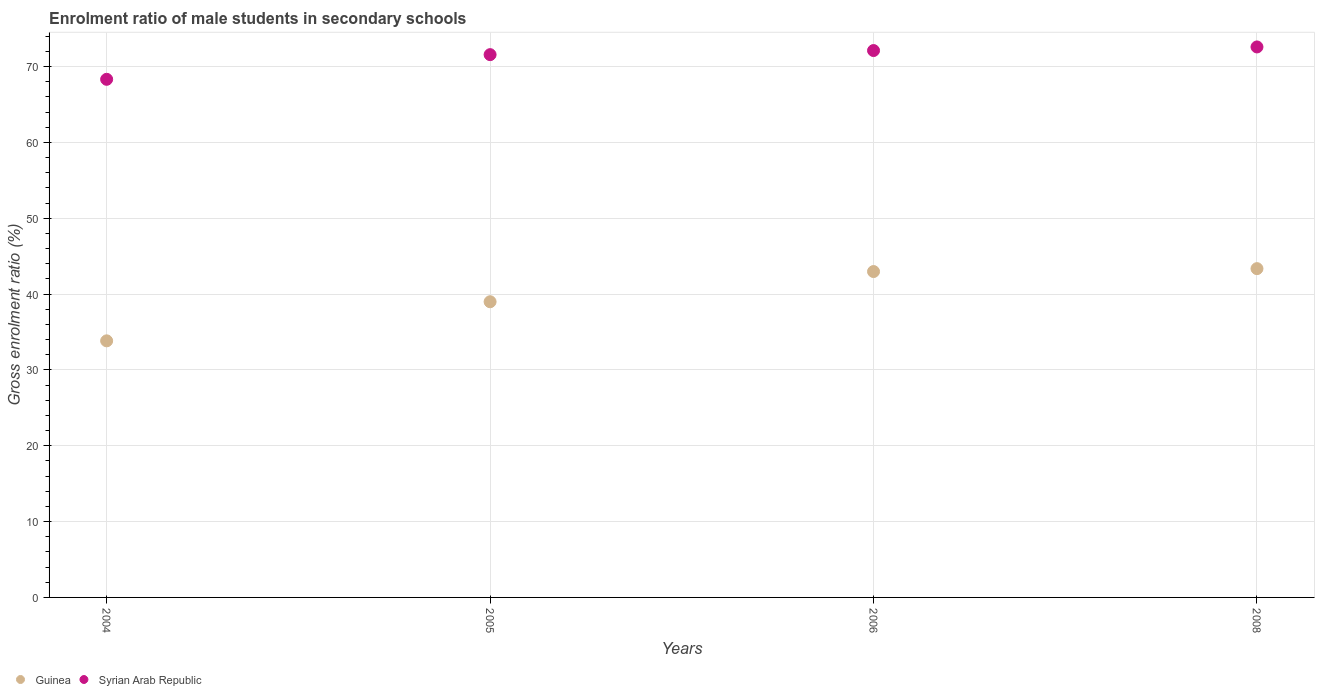What is the enrolment ratio of male students in secondary schools in Guinea in 2004?
Give a very brief answer. 33.84. Across all years, what is the maximum enrolment ratio of male students in secondary schools in Guinea?
Provide a succinct answer. 43.36. Across all years, what is the minimum enrolment ratio of male students in secondary schools in Syrian Arab Republic?
Your answer should be very brief. 68.33. In which year was the enrolment ratio of male students in secondary schools in Syrian Arab Republic maximum?
Make the answer very short. 2008. In which year was the enrolment ratio of male students in secondary schools in Guinea minimum?
Keep it short and to the point. 2004. What is the total enrolment ratio of male students in secondary schools in Syrian Arab Republic in the graph?
Ensure brevity in your answer.  284.63. What is the difference between the enrolment ratio of male students in secondary schools in Syrian Arab Republic in 2006 and that in 2008?
Make the answer very short. -0.48. What is the difference between the enrolment ratio of male students in secondary schools in Guinea in 2006 and the enrolment ratio of male students in secondary schools in Syrian Arab Republic in 2008?
Your response must be concise. -29.62. What is the average enrolment ratio of male students in secondary schools in Guinea per year?
Provide a succinct answer. 39.79. In the year 2005, what is the difference between the enrolment ratio of male students in secondary schools in Syrian Arab Republic and enrolment ratio of male students in secondary schools in Guinea?
Make the answer very short. 32.59. What is the ratio of the enrolment ratio of male students in secondary schools in Syrian Arab Republic in 2004 to that in 2006?
Keep it short and to the point. 0.95. Is the enrolment ratio of male students in secondary schools in Guinea in 2004 less than that in 2006?
Offer a terse response. Yes. Is the difference between the enrolment ratio of male students in secondary schools in Syrian Arab Republic in 2006 and 2008 greater than the difference between the enrolment ratio of male students in secondary schools in Guinea in 2006 and 2008?
Offer a very short reply. No. What is the difference between the highest and the second highest enrolment ratio of male students in secondary schools in Syrian Arab Republic?
Provide a short and direct response. 0.48. What is the difference between the highest and the lowest enrolment ratio of male students in secondary schools in Syrian Arab Republic?
Your answer should be very brief. 4.27. In how many years, is the enrolment ratio of male students in secondary schools in Syrian Arab Republic greater than the average enrolment ratio of male students in secondary schools in Syrian Arab Republic taken over all years?
Your answer should be very brief. 3. Is the sum of the enrolment ratio of male students in secondary schools in Syrian Arab Republic in 2004 and 2005 greater than the maximum enrolment ratio of male students in secondary schools in Guinea across all years?
Make the answer very short. Yes. Is the enrolment ratio of male students in secondary schools in Syrian Arab Republic strictly greater than the enrolment ratio of male students in secondary schools in Guinea over the years?
Ensure brevity in your answer.  Yes. Is the enrolment ratio of male students in secondary schools in Guinea strictly less than the enrolment ratio of male students in secondary schools in Syrian Arab Republic over the years?
Your answer should be compact. Yes. How many dotlines are there?
Offer a terse response. 2. How many years are there in the graph?
Offer a terse response. 4. Are the values on the major ticks of Y-axis written in scientific E-notation?
Provide a short and direct response. No. Does the graph contain any zero values?
Make the answer very short. No. How many legend labels are there?
Offer a terse response. 2. What is the title of the graph?
Offer a very short reply. Enrolment ratio of male students in secondary schools. What is the Gross enrolment ratio (%) of Guinea in 2004?
Your answer should be compact. 33.84. What is the Gross enrolment ratio (%) in Syrian Arab Republic in 2004?
Give a very brief answer. 68.33. What is the Gross enrolment ratio (%) in Guinea in 2005?
Your answer should be very brief. 39. What is the Gross enrolment ratio (%) in Syrian Arab Republic in 2005?
Your answer should be very brief. 71.58. What is the Gross enrolment ratio (%) in Guinea in 2006?
Offer a terse response. 42.98. What is the Gross enrolment ratio (%) in Syrian Arab Republic in 2006?
Ensure brevity in your answer.  72.12. What is the Gross enrolment ratio (%) of Guinea in 2008?
Your response must be concise. 43.36. What is the Gross enrolment ratio (%) in Syrian Arab Republic in 2008?
Provide a succinct answer. 72.6. Across all years, what is the maximum Gross enrolment ratio (%) of Guinea?
Offer a terse response. 43.36. Across all years, what is the maximum Gross enrolment ratio (%) of Syrian Arab Republic?
Provide a succinct answer. 72.6. Across all years, what is the minimum Gross enrolment ratio (%) in Guinea?
Your response must be concise. 33.84. Across all years, what is the minimum Gross enrolment ratio (%) in Syrian Arab Republic?
Keep it short and to the point. 68.33. What is the total Gross enrolment ratio (%) of Guinea in the graph?
Make the answer very short. 159.17. What is the total Gross enrolment ratio (%) of Syrian Arab Republic in the graph?
Your response must be concise. 284.63. What is the difference between the Gross enrolment ratio (%) of Guinea in 2004 and that in 2005?
Give a very brief answer. -5.16. What is the difference between the Gross enrolment ratio (%) in Syrian Arab Republic in 2004 and that in 2005?
Ensure brevity in your answer.  -3.25. What is the difference between the Gross enrolment ratio (%) in Guinea in 2004 and that in 2006?
Ensure brevity in your answer.  -9.14. What is the difference between the Gross enrolment ratio (%) of Syrian Arab Republic in 2004 and that in 2006?
Make the answer very short. -3.79. What is the difference between the Gross enrolment ratio (%) of Guinea in 2004 and that in 2008?
Provide a succinct answer. -9.52. What is the difference between the Gross enrolment ratio (%) in Syrian Arab Republic in 2004 and that in 2008?
Your answer should be very brief. -4.27. What is the difference between the Gross enrolment ratio (%) in Guinea in 2005 and that in 2006?
Offer a terse response. -3.98. What is the difference between the Gross enrolment ratio (%) of Syrian Arab Republic in 2005 and that in 2006?
Your answer should be compact. -0.54. What is the difference between the Gross enrolment ratio (%) in Guinea in 2005 and that in 2008?
Your response must be concise. -4.37. What is the difference between the Gross enrolment ratio (%) in Syrian Arab Republic in 2005 and that in 2008?
Provide a short and direct response. -1.02. What is the difference between the Gross enrolment ratio (%) of Guinea in 2006 and that in 2008?
Your answer should be very brief. -0.38. What is the difference between the Gross enrolment ratio (%) of Syrian Arab Republic in 2006 and that in 2008?
Keep it short and to the point. -0.48. What is the difference between the Gross enrolment ratio (%) of Guinea in 2004 and the Gross enrolment ratio (%) of Syrian Arab Republic in 2005?
Give a very brief answer. -37.74. What is the difference between the Gross enrolment ratio (%) in Guinea in 2004 and the Gross enrolment ratio (%) in Syrian Arab Republic in 2006?
Offer a terse response. -38.28. What is the difference between the Gross enrolment ratio (%) of Guinea in 2004 and the Gross enrolment ratio (%) of Syrian Arab Republic in 2008?
Your response must be concise. -38.76. What is the difference between the Gross enrolment ratio (%) in Guinea in 2005 and the Gross enrolment ratio (%) in Syrian Arab Republic in 2006?
Your answer should be very brief. -33.13. What is the difference between the Gross enrolment ratio (%) in Guinea in 2005 and the Gross enrolment ratio (%) in Syrian Arab Republic in 2008?
Your answer should be compact. -33.6. What is the difference between the Gross enrolment ratio (%) of Guinea in 2006 and the Gross enrolment ratio (%) of Syrian Arab Republic in 2008?
Your answer should be compact. -29.62. What is the average Gross enrolment ratio (%) of Guinea per year?
Your answer should be very brief. 39.79. What is the average Gross enrolment ratio (%) in Syrian Arab Republic per year?
Your answer should be compact. 71.16. In the year 2004, what is the difference between the Gross enrolment ratio (%) of Guinea and Gross enrolment ratio (%) of Syrian Arab Republic?
Your answer should be compact. -34.49. In the year 2005, what is the difference between the Gross enrolment ratio (%) of Guinea and Gross enrolment ratio (%) of Syrian Arab Republic?
Keep it short and to the point. -32.59. In the year 2006, what is the difference between the Gross enrolment ratio (%) of Guinea and Gross enrolment ratio (%) of Syrian Arab Republic?
Keep it short and to the point. -29.15. In the year 2008, what is the difference between the Gross enrolment ratio (%) in Guinea and Gross enrolment ratio (%) in Syrian Arab Republic?
Offer a terse response. -29.24. What is the ratio of the Gross enrolment ratio (%) of Guinea in 2004 to that in 2005?
Ensure brevity in your answer.  0.87. What is the ratio of the Gross enrolment ratio (%) of Syrian Arab Republic in 2004 to that in 2005?
Your answer should be very brief. 0.95. What is the ratio of the Gross enrolment ratio (%) in Guinea in 2004 to that in 2006?
Your answer should be compact. 0.79. What is the ratio of the Gross enrolment ratio (%) in Syrian Arab Republic in 2004 to that in 2006?
Your response must be concise. 0.95. What is the ratio of the Gross enrolment ratio (%) of Guinea in 2004 to that in 2008?
Provide a succinct answer. 0.78. What is the ratio of the Gross enrolment ratio (%) in Syrian Arab Republic in 2004 to that in 2008?
Your response must be concise. 0.94. What is the ratio of the Gross enrolment ratio (%) of Guinea in 2005 to that in 2006?
Offer a very short reply. 0.91. What is the ratio of the Gross enrolment ratio (%) in Syrian Arab Republic in 2005 to that in 2006?
Make the answer very short. 0.99. What is the ratio of the Gross enrolment ratio (%) of Guinea in 2005 to that in 2008?
Offer a terse response. 0.9. What is the ratio of the Gross enrolment ratio (%) of Guinea in 2006 to that in 2008?
Provide a succinct answer. 0.99. What is the difference between the highest and the second highest Gross enrolment ratio (%) of Guinea?
Ensure brevity in your answer.  0.38. What is the difference between the highest and the second highest Gross enrolment ratio (%) of Syrian Arab Republic?
Provide a short and direct response. 0.48. What is the difference between the highest and the lowest Gross enrolment ratio (%) in Guinea?
Keep it short and to the point. 9.52. What is the difference between the highest and the lowest Gross enrolment ratio (%) in Syrian Arab Republic?
Keep it short and to the point. 4.27. 